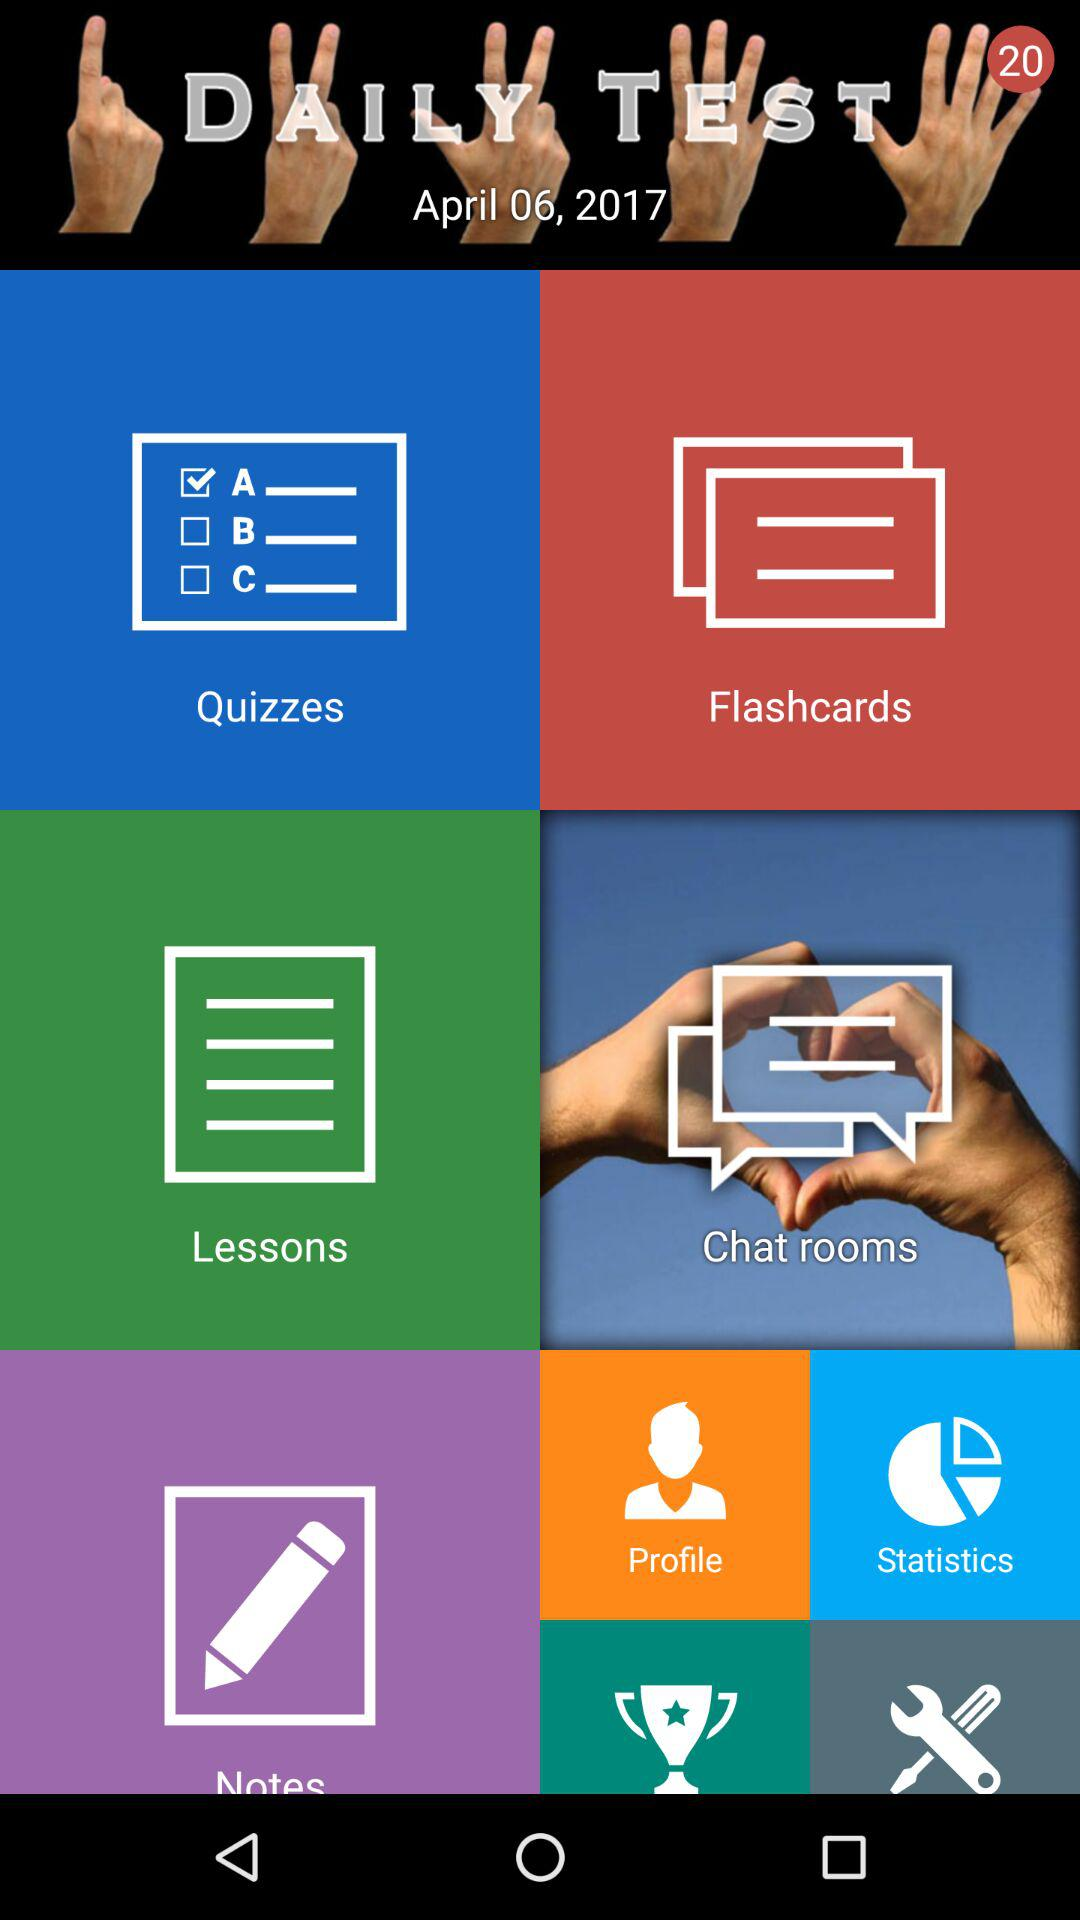What date is displayed on the screen? The displayed date is April 06, 2017. 